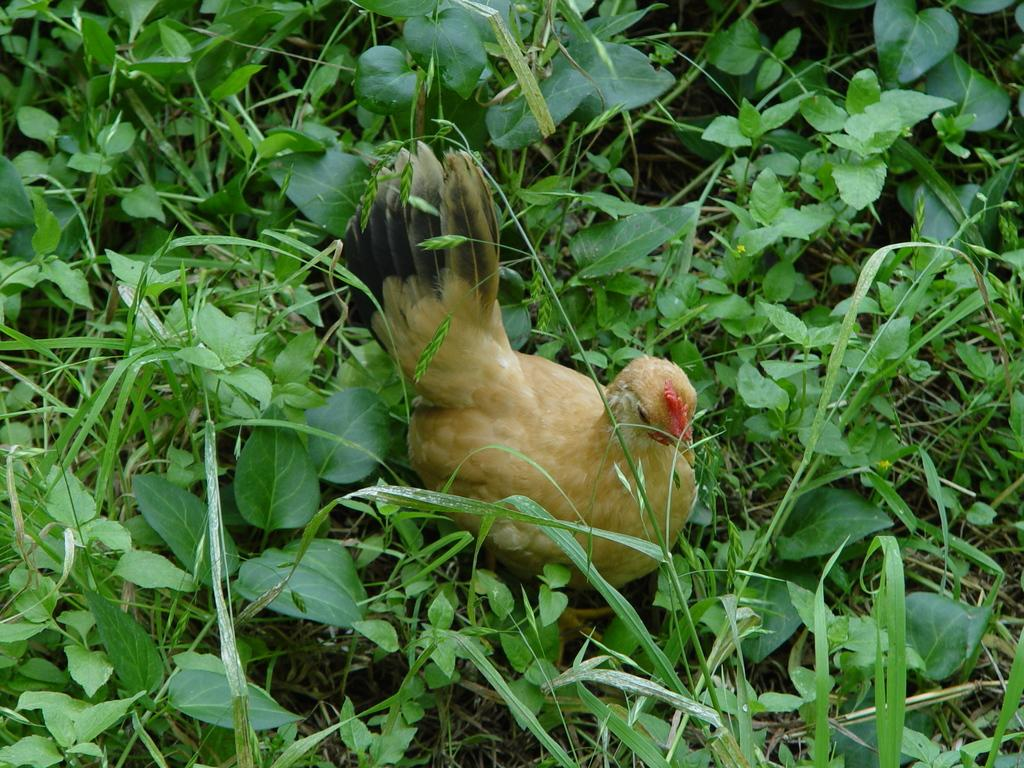What type of animal is in the image? There is a hen in the image. What other elements can be seen in the image? There are plants in the image. What is the primary ground cover visible in the image? Grass is present all over the image. Where is the drawer located in the image? There is no drawer present in the image. How many grapes can be seen hanging from the hen? There are no grapes present in the image, and the hen is not interacting with any grapes. 